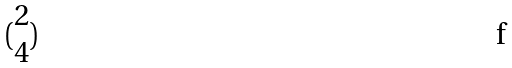Convert formula to latex. <formula><loc_0><loc_0><loc_500><loc_500>( \begin{matrix} 2 \\ 4 \end{matrix} )</formula> 